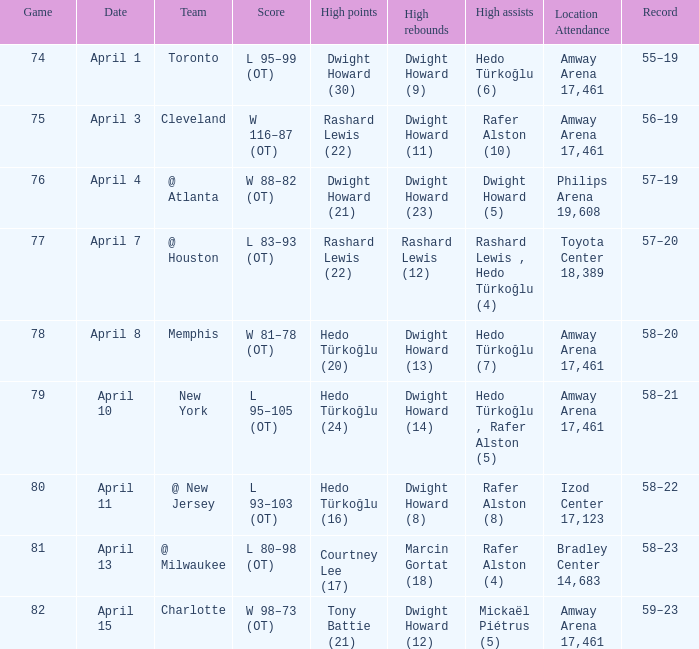What's the highest number of rebounds recorded in game 81? Marcin Gortat (18). Write the full table. {'header': ['Game', 'Date', 'Team', 'Score', 'High points', 'High rebounds', 'High assists', 'Location Attendance', 'Record'], 'rows': [['74', 'April 1', 'Toronto', 'L 95–99 (OT)', 'Dwight Howard (30)', 'Dwight Howard (9)', 'Hedo Türkoğlu (6)', 'Amway Arena 17,461', '55–19'], ['75', 'April 3', 'Cleveland', 'W 116–87 (OT)', 'Rashard Lewis (22)', 'Dwight Howard (11)', 'Rafer Alston (10)', 'Amway Arena 17,461', '56–19'], ['76', 'April 4', '@ Atlanta', 'W 88–82 (OT)', 'Dwight Howard (21)', 'Dwight Howard (23)', 'Dwight Howard (5)', 'Philips Arena 19,608', '57–19'], ['77', 'April 7', '@ Houston', 'L 83–93 (OT)', 'Rashard Lewis (22)', 'Rashard Lewis (12)', 'Rashard Lewis , Hedo Türkoğlu (4)', 'Toyota Center 18,389', '57–20'], ['78', 'April 8', 'Memphis', 'W 81–78 (OT)', 'Hedo Türkoğlu (20)', 'Dwight Howard (13)', 'Hedo Türkoğlu (7)', 'Amway Arena 17,461', '58–20'], ['79', 'April 10', 'New York', 'L 95–105 (OT)', 'Hedo Türkoğlu (24)', 'Dwight Howard (14)', 'Hedo Türkoğlu , Rafer Alston (5)', 'Amway Arena 17,461', '58–21'], ['80', 'April 11', '@ New Jersey', 'L 93–103 (OT)', 'Hedo Türkoğlu (16)', 'Dwight Howard (8)', 'Rafer Alston (8)', 'Izod Center 17,123', '58–22'], ['81', 'April 13', '@ Milwaukee', 'L 80–98 (OT)', 'Courtney Lee (17)', 'Marcin Gortat (18)', 'Rafer Alston (4)', 'Bradley Center 14,683', '58–23'], ['82', 'April 15', 'Charlotte', 'W 98–73 (OT)', 'Tony Battie (21)', 'Dwight Howard (12)', 'Mickaël Piétrus (5)', 'Amway Arena 17,461', '59–23']]} 